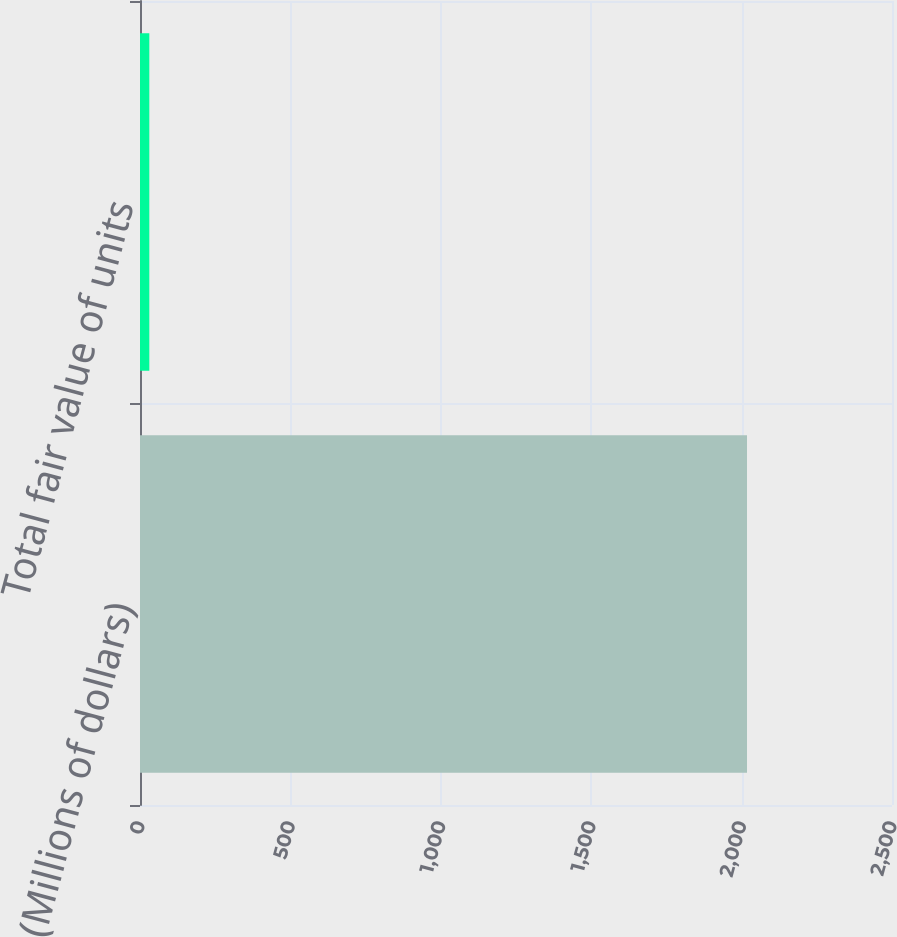Convert chart to OTSL. <chart><loc_0><loc_0><loc_500><loc_500><bar_chart><fcel>(Millions of dollars)<fcel>Total fair value of units<nl><fcel>2018<fcel>31<nl></chart> 